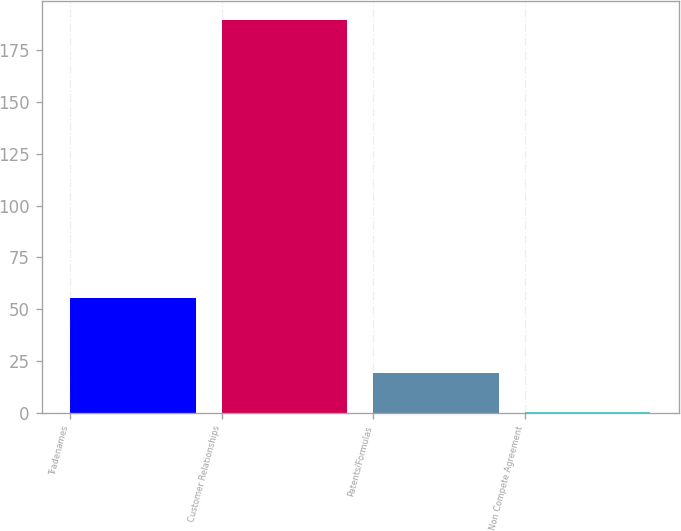<chart> <loc_0><loc_0><loc_500><loc_500><bar_chart><fcel>Tradenames<fcel>Customer Relationships<fcel>Patents/Formulas<fcel>Non Compete Agreement<nl><fcel>55.6<fcel>189.5<fcel>19.13<fcel>0.2<nl></chart> 